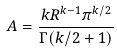<formula> <loc_0><loc_0><loc_500><loc_500>A = \frac { k R ^ { k - 1 } \pi ^ { k / 2 } } { \Gamma ( k / 2 + 1 ) }</formula> 